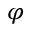Convert formula to latex. <formula><loc_0><loc_0><loc_500><loc_500>\varphi</formula> 